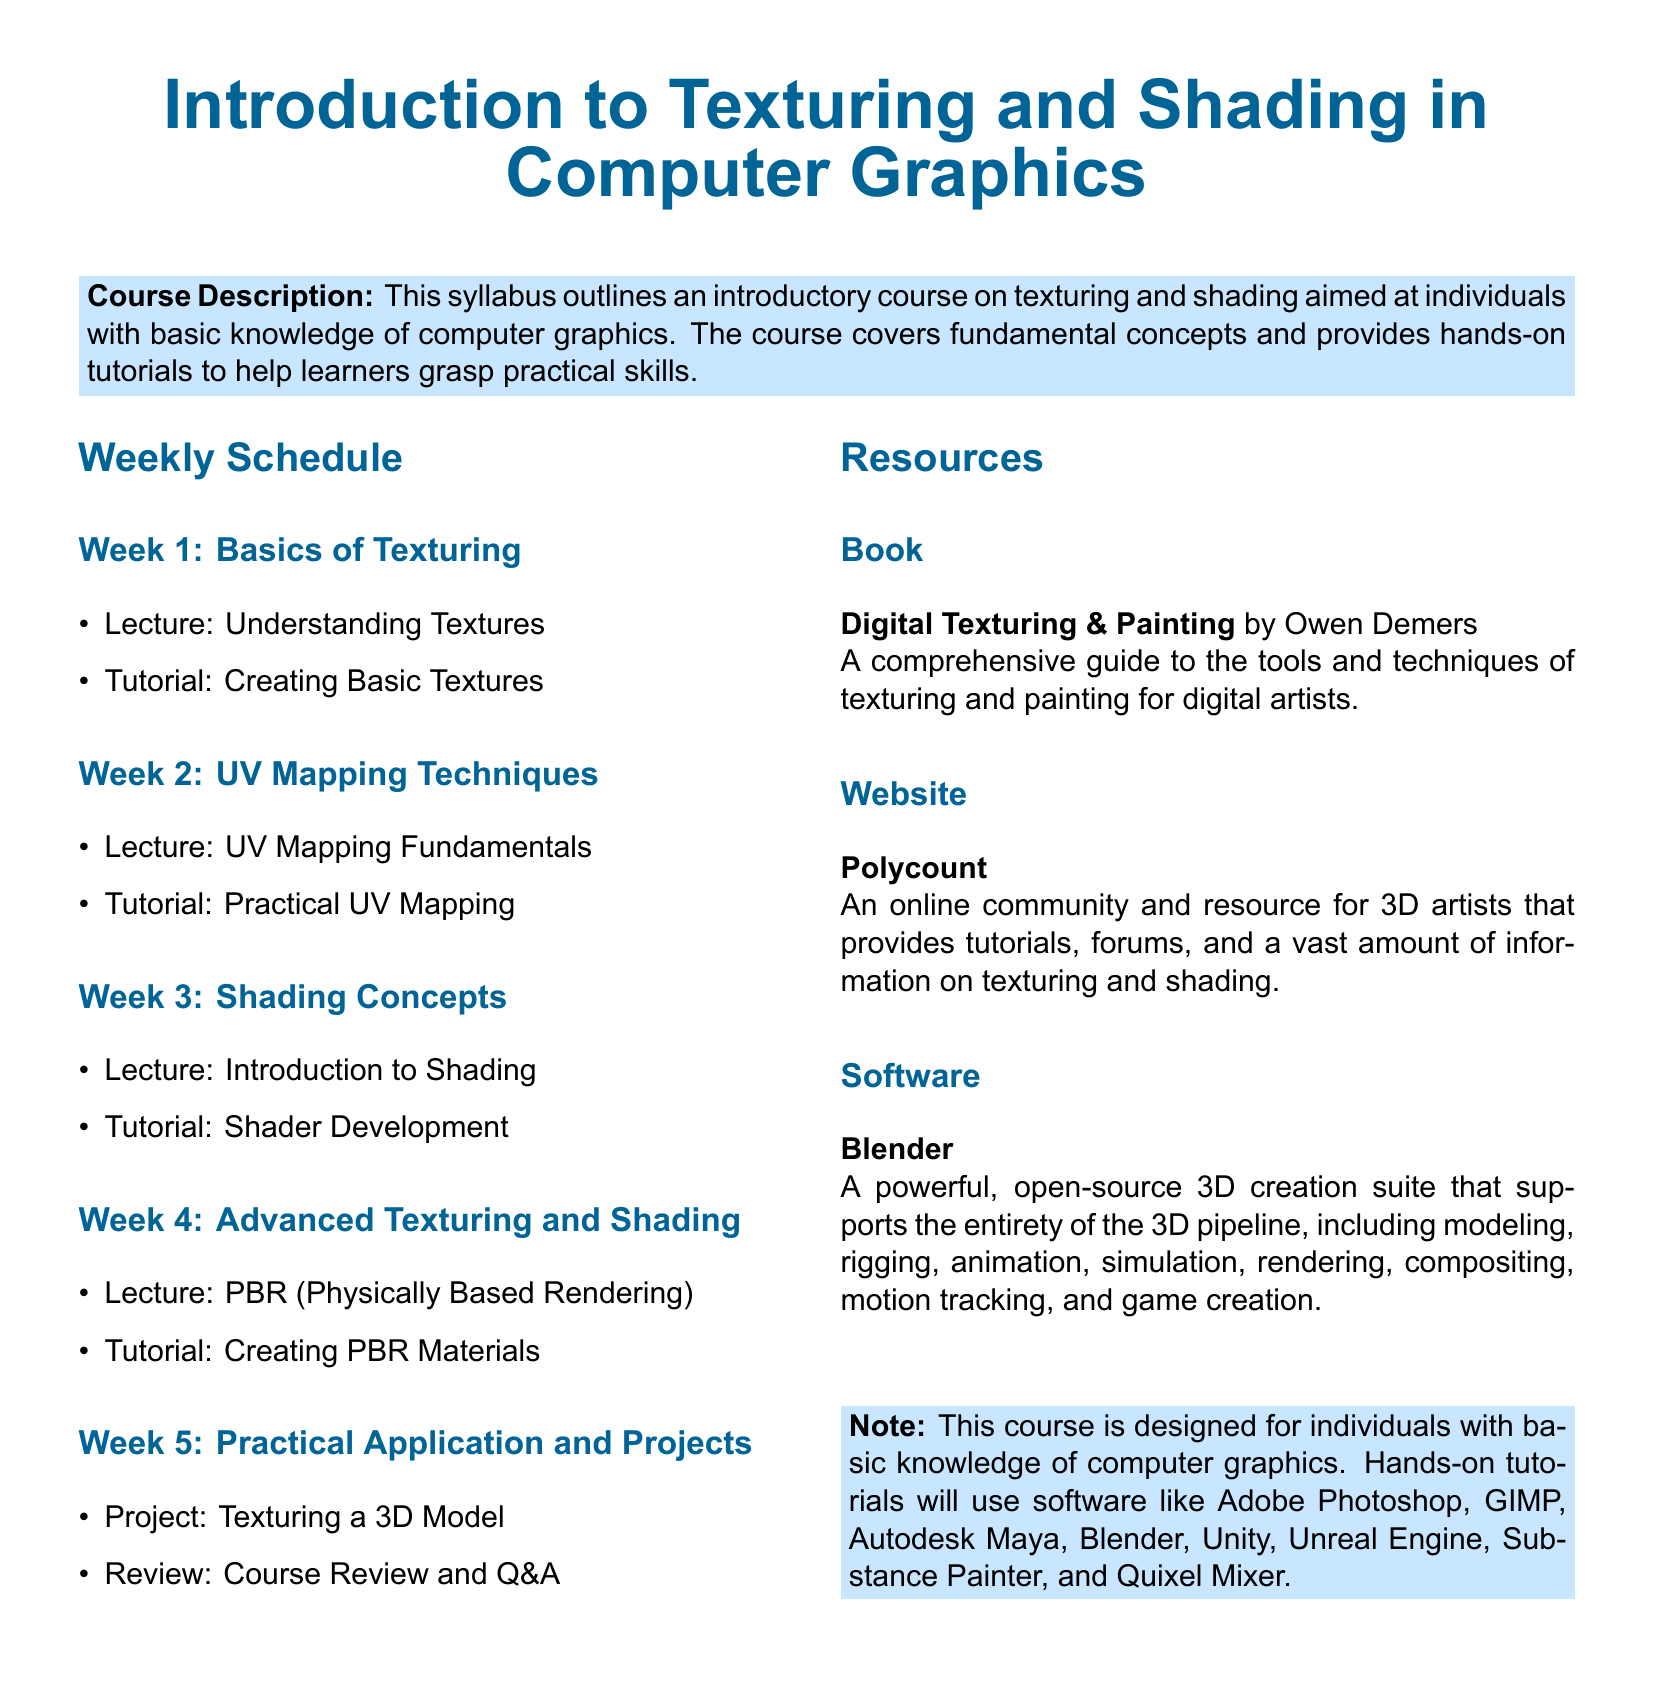What is the title of the course? The title is prominently displayed at the beginning of the document, as "Introduction to Texturing and Shading in Computer Graphics."
Answer: Introduction to Texturing and Shading in Computer Graphics How many weeks are in the course schedule? The document outlines a weekly schedule that consists of five distinct weeks, which are detailed in the course schedule.
Answer: 5 What is the focus of Week 2? Week 2 focuses on UV Mapping Techniques, which includes a lecture and a tutorial on the subject.
Answer: UV Mapping Techniques What book is recommended for the course? The document lists a specific book aimed at helping learners understand texturing and painting, which is crucial for the course.
Answer: Digital Texturing & Painting by Owen Demers Which software will be used in the hands-on tutorials? The syllabus notes specific software that will be employed for practical tutorials, indicating its relevance to the course.
Answer: Adobe Photoshop, GIMP, Autodesk Maya, Blender, Unity, Unreal Engine, Substance Painter, and Quixel Mixer What is the topic of the Project in Week 5? The project in Week 5 involves a specific activity related to the learning objectives of the course, focusing on practical application.
Answer: Texturing a 3D Model Which week covers PBR (Physically Based Rendering)? The document specifies when advanced techniques, such as PBR, will be introduced within the course schedule.
Answer: Week 4 What is the purpose of the review at the end of Week 5? The review in Week 5 serves a specific function in relation to the overall learning process, emphasizing its importance for students.
Answer: Course Review and Q&A 